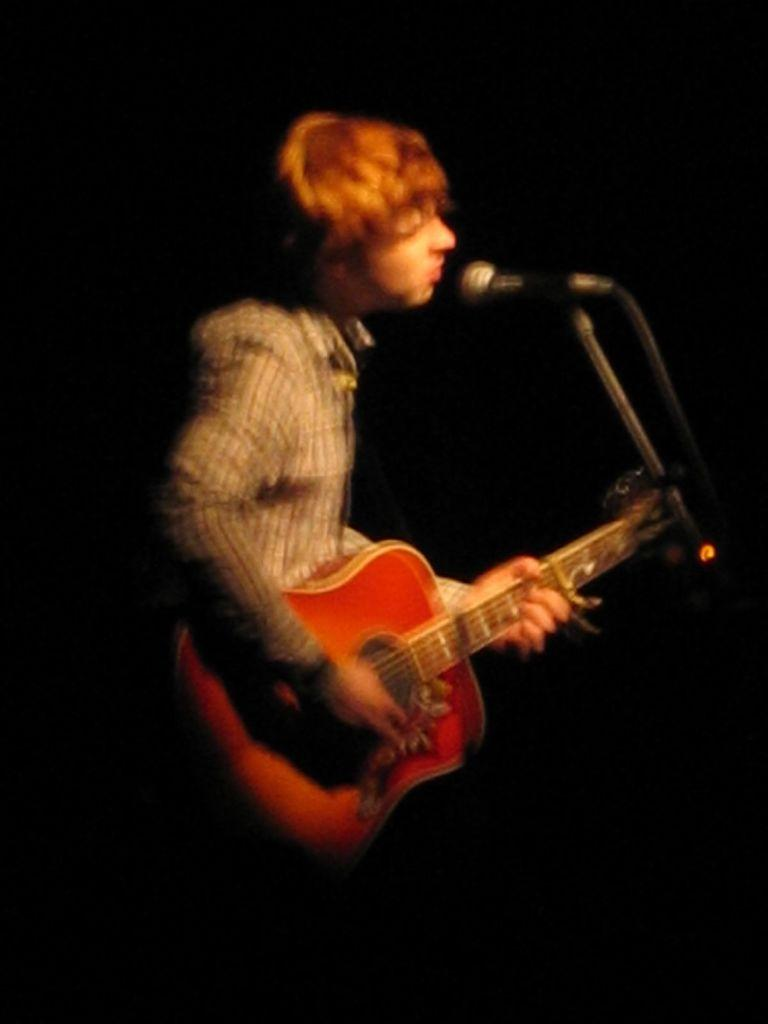Who is the main subject in the image? There is a man in the image. What is the man holding in the image? The man is holding a guitar. What is the man doing with the guitar? The man is playing the guitar. What other action is the man performing in the image? The man is singing. What device is the man using to amplify his voice? The man is using a microphone. How would you describe the lighting in the image? The background of the image is dark. Can you see any flames coming from the man's chin in the image? No, there are no flames visible in the image, and the man's chin is not mentioned in the provided facts. 